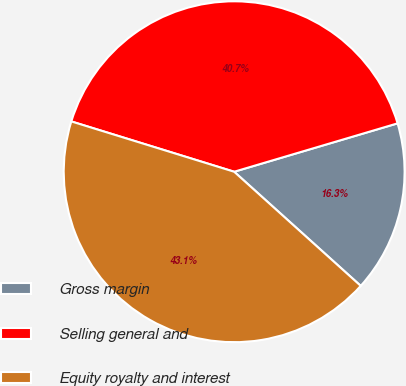<chart> <loc_0><loc_0><loc_500><loc_500><pie_chart><fcel>Gross margin<fcel>Selling general and<fcel>Equity royalty and interest<nl><fcel>16.26%<fcel>40.65%<fcel>43.09%<nl></chart> 